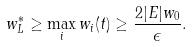<formula> <loc_0><loc_0><loc_500><loc_500>w ^ { * } _ { L } \geq \max _ { i } w _ { i } ( t ) \geq \frac { 2 | E | w _ { 0 } } { \epsilon } .</formula> 